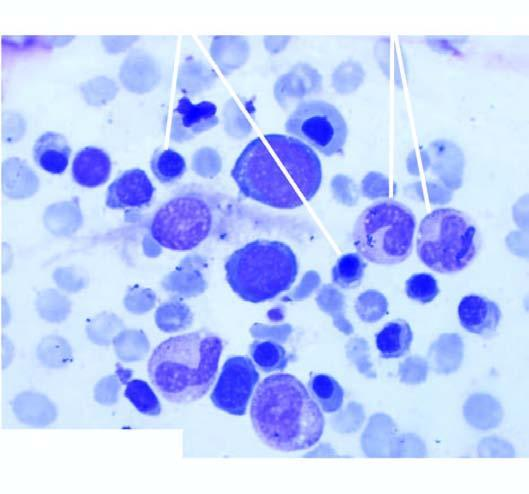what is there?
Answer the question using a single word or phrase. Moderate microcytosis and hypochromia 